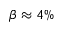Convert formula to latex. <formula><loc_0><loc_0><loc_500><loc_500>\beta \approx 4 \%</formula> 